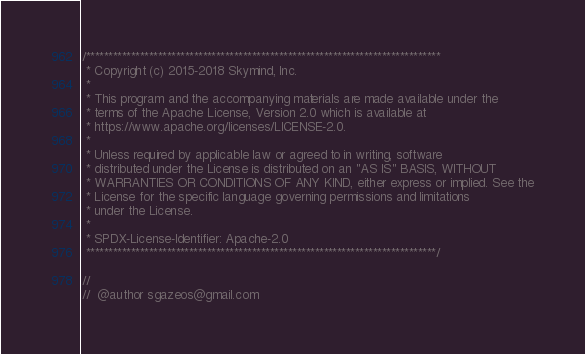<code> <loc_0><loc_0><loc_500><loc_500><_Cuda_>/*******************************************************************************
 * Copyright (c) 2015-2018 Skymind, Inc.
 *
 * This program and the accompanying materials are made available under the
 * terms of the Apache License, Version 2.0 which is available at
 * https://www.apache.org/licenses/LICENSE-2.0.
 *
 * Unless required by applicable law or agreed to in writing, software
 * distributed under the License is distributed on an "AS IS" BASIS, WITHOUT
 * WARRANTIES OR CONDITIONS OF ANY KIND, either express or implied. See the
 * License for the specific language governing permissions and limitations
 * under the License.
 *
 * SPDX-License-Identifier: Apache-2.0
 ******************************************************************************/

//
//  @author sgazeos@gmail.com</code> 